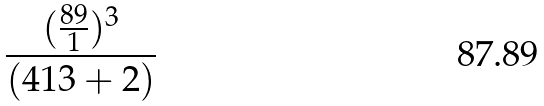<formula> <loc_0><loc_0><loc_500><loc_500>\frac { ( \frac { 8 9 } { 1 } ) ^ { 3 } } { ( 4 1 3 + 2 ) }</formula> 